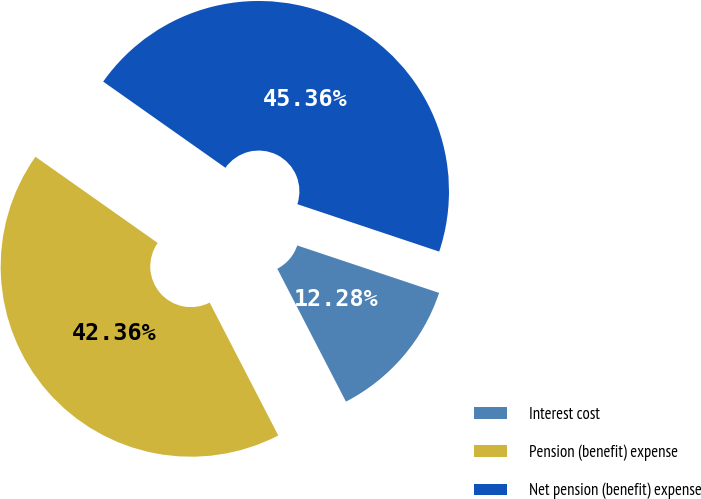Convert chart. <chart><loc_0><loc_0><loc_500><loc_500><pie_chart><fcel>Interest cost<fcel>Pension (benefit) expense<fcel>Net pension (benefit) expense<nl><fcel>12.28%<fcel>42.36%<fcel>45.36%<nl></chart> 